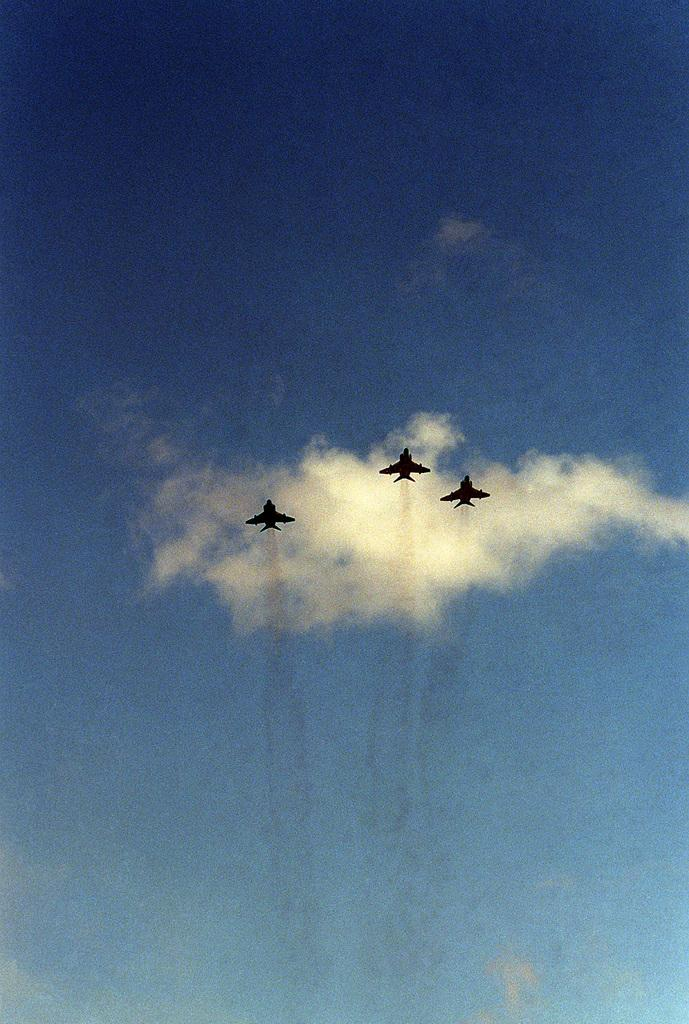What is the main subject of the image? The main subject of the image is three aircrafts. What are the aircrafts doing in the image? The aircrafts are flying in the air. What can be seen in the background of the image? There is a sky visible in the background of the image. What is the condition of the sky in the image? Clouds are present in the sky. What type of stamp can be seen on the wing of the aircraft? There is no stamp visible on the wing of the aircraft in the image. How does the roll of paper affect the flight of the aircraft in the image? There is no roll of paper present in the image, so it cannot affect the flight of the aircraft. 